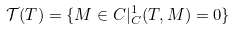<formula> <loc_0><loc_0><loc_500><loc_500>\mathcal { T } ( T ) = \{ M \in C | _ { C } ^ { 1 } ( T , M ) = 0 \}</formula> 